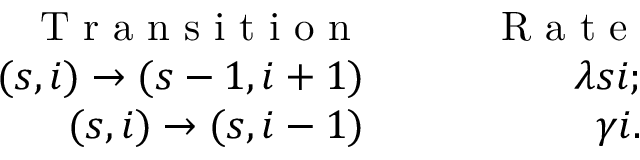Convert formula to latex. <formula><loc_0><loc_0><loc_500><loc_500>\begin{array} { r l r } { T r a n s i t i o n } & \quad } & { R a t e } \\ { ( s , i ) \to ( s - 1 , i + 1 ) } & \quad } & { \lambda s i ; } \\ { ( s , i ) \to ( s , i - 1 ) } & \quad } & { \gamma i . } \end{array}</formula> 